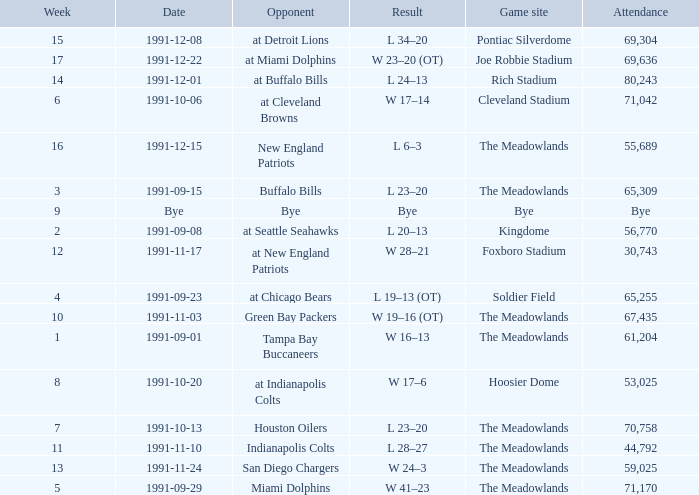What was the Attendance in Week 17? 69636.0. 